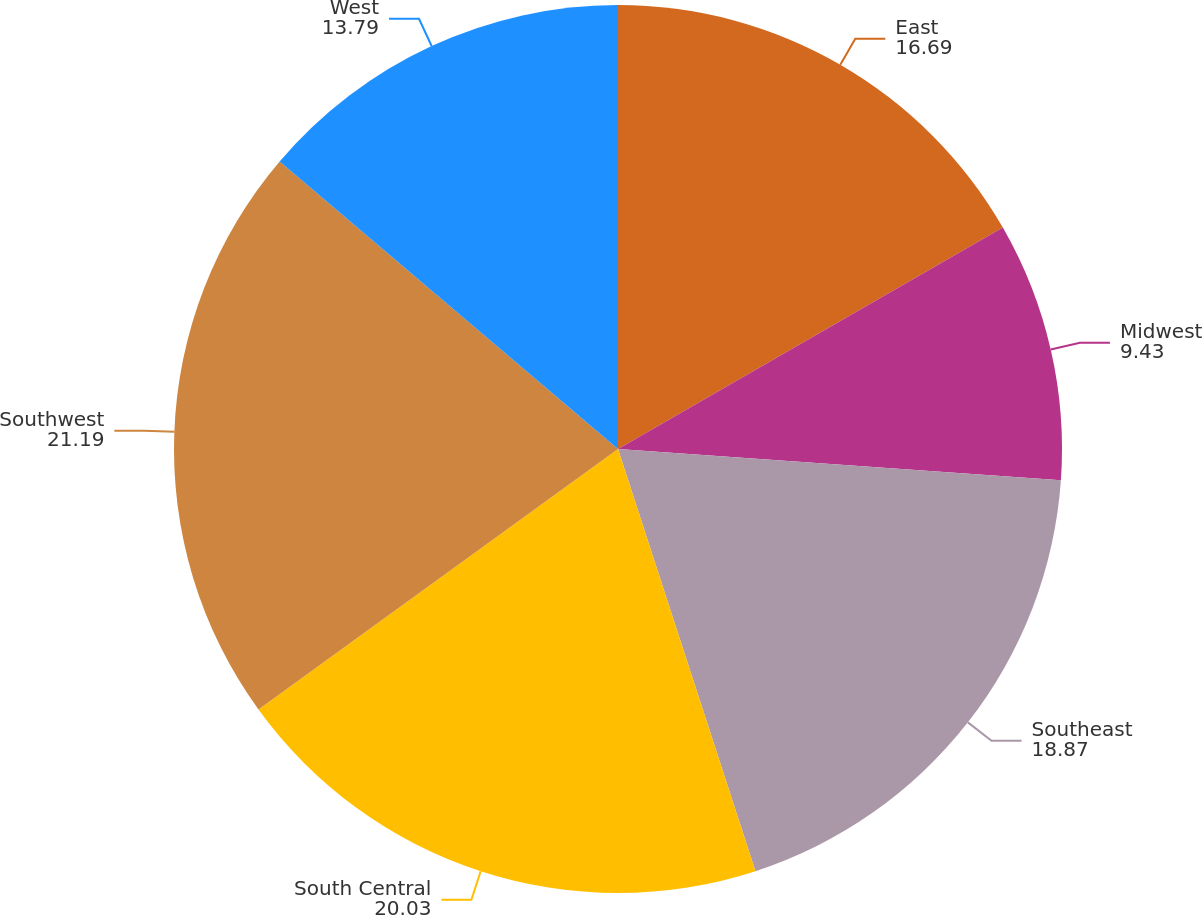Convert chart. <chart><loc_0><loc_0><loc_500><loc_500><pie_chart><fcel>East<fcel>Midwest<fcel>Southeast<fcel>South Central<fcel>Southwest<fcel>West<nl><fcel>16.69%<fcel>9.43%<fcel>18.87%<fcel>20.03%<fcel>21.19%<fcel>13.79%<nl></chart> 